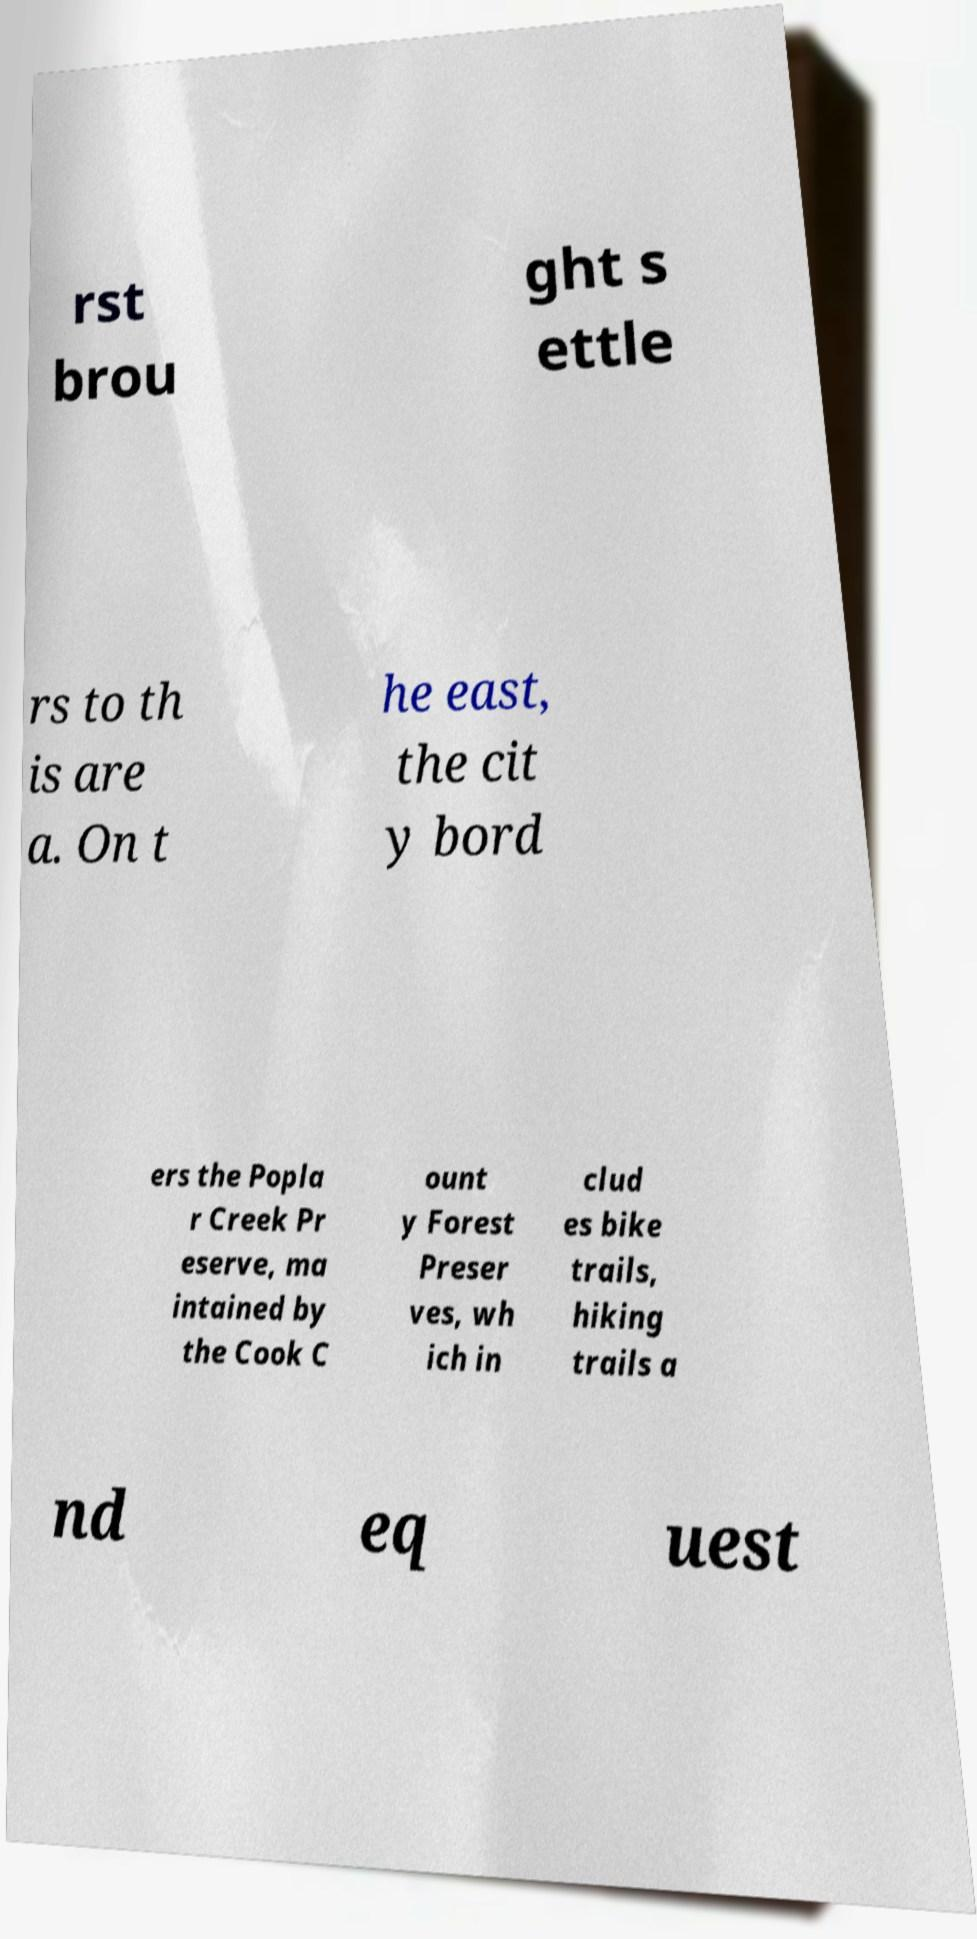Please read and relay the text visible in this image. What does it say? rst brou ght s ettle rs to th is are a. On t he east, the cit y bord ers the Popla r Creek Pr eserve, ma intained by the Cook C ount y Forest Preser ves, wh ich in clud es bike trails, hiking trails a nd eq uest 